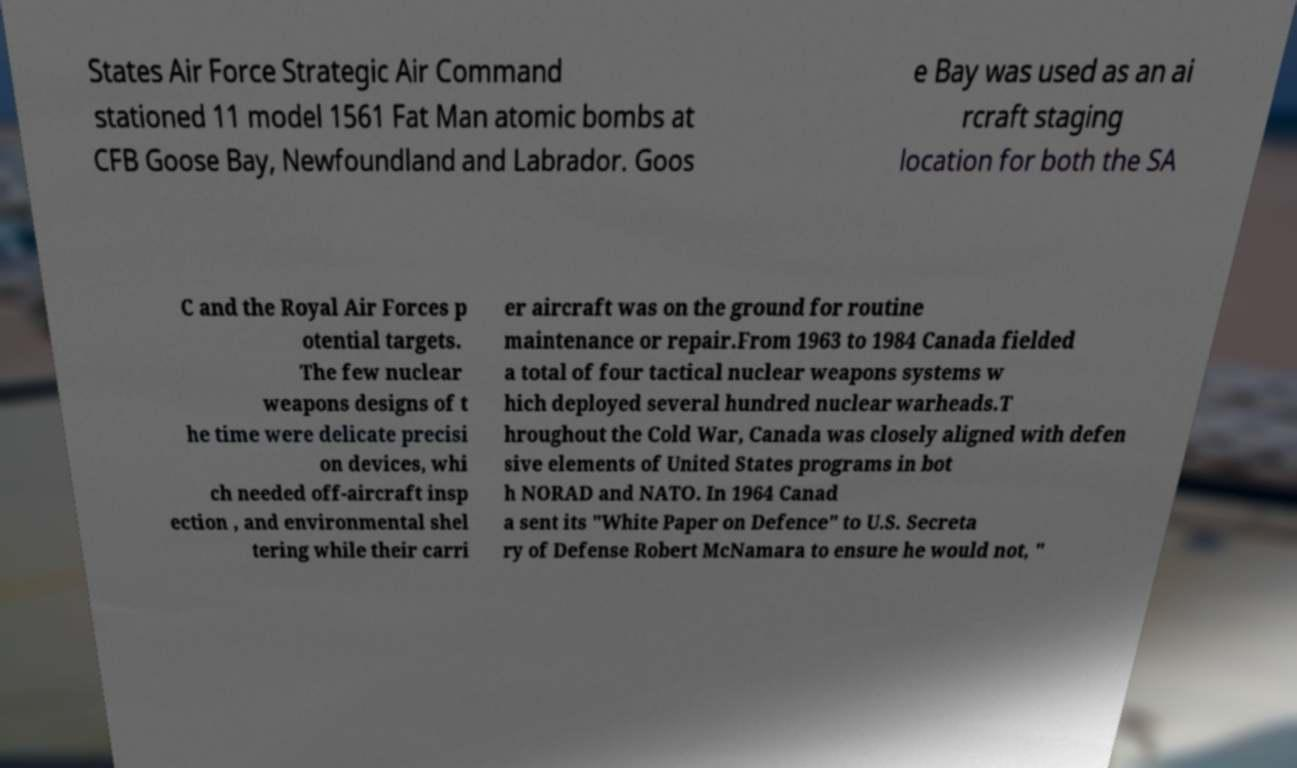Please identify and transcribe the text found in this image. States Air Force Strategic Air Command stationed 11 model 1561 Fat Man atomic bombs at CFB Goose Bay, Newfoundland and Labrador. Goos e Bay was used as an ai rcraft staging location for both the SA C and the Royal Air Forces p otential targets. The few nuclear weapons designs of t he time were delicate precisi on devices, whi ch needed off-aircraft insp ection , and environmental shel tering while their carri er aircraft was on the ground for routine maintenance or repair.From 1963 to 1984 Canada fielded a total of four tactical nuclear weapons systems w hich deployed several hundred nuclear warheads.T hroughout the Cold War, Canada was closely aligned with defen sive elements of United States programs in bot h NORAD and NATO. In 1964 Canad a sent its "White Paper on Defence" to U.S. Secreta ry of Defense Robert McNamara to ensure he would not, " 